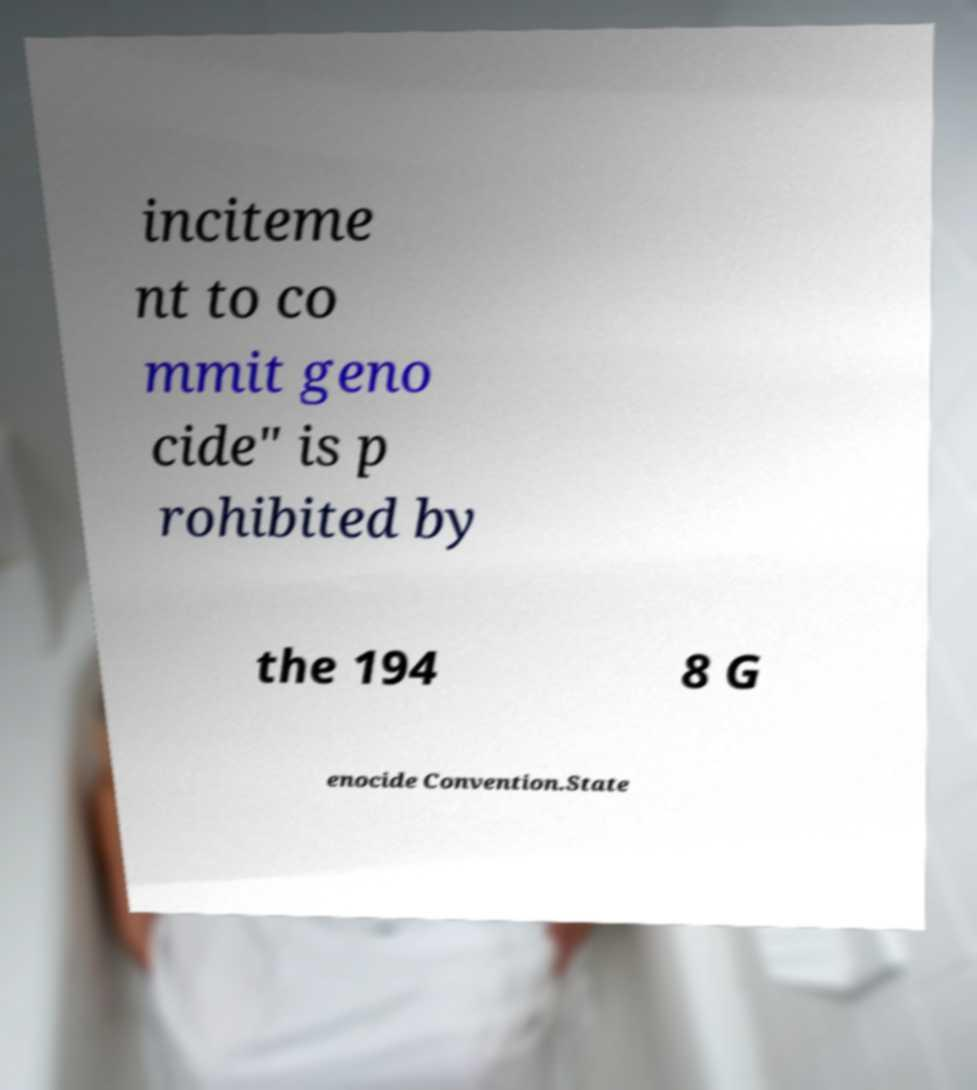I need the written content from this picture converted into text. Can you do that? inciteme nt to co mmit geno cide" is p rohibited by the 194 8 G enocide Convention.State 